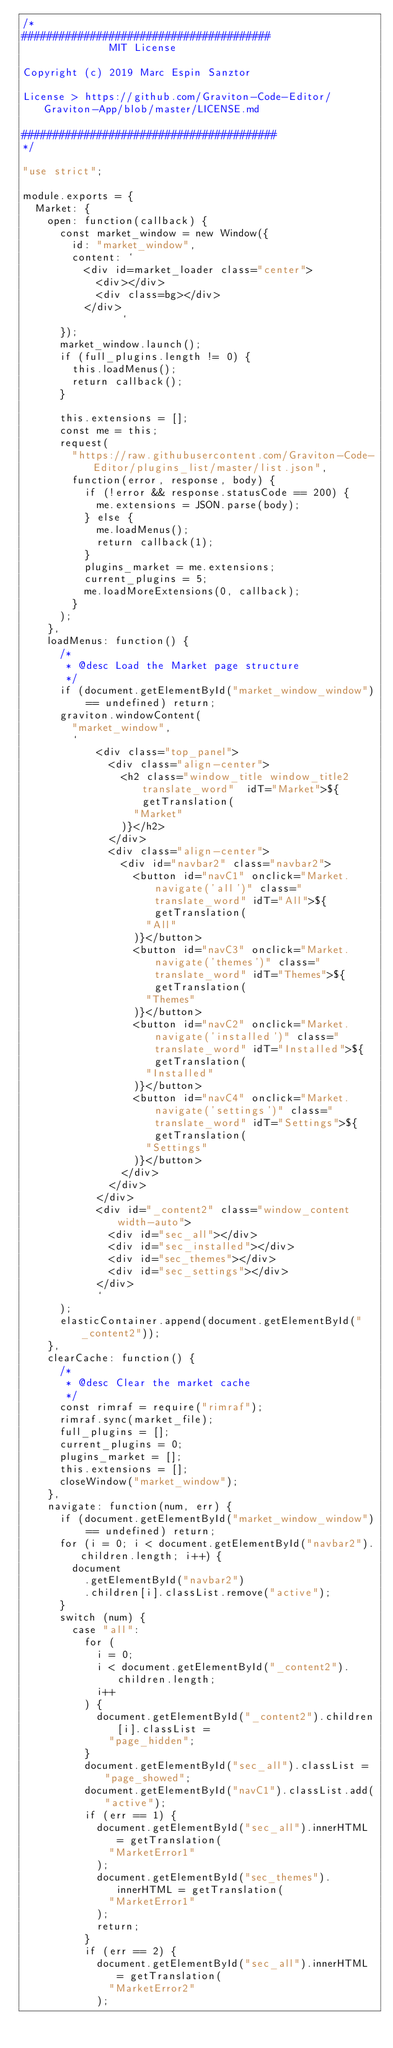<code> <loc_0><loc_0><loc_500><loc_500><_JavaScript_>/*
########################################
              MIT License

Copyright (c) 2019 Marc Espin Sanztor

License > https://github.com/Graviton-Code-Editor/Graviton-App/blob/master/LICENSE.md

#########################################
*/

"use strict";

module.exports = {
  Market: {
    open: function(callback) {
      const market_window = new Window({
        id: "market_window",
        content: `
          <div id=market_loader class="center">
            <div></div>
            <div class=bg></div>
          </div>
                `
      });
      market_window.launch();
      if (full_plugins.length != 0) {
        this.loadMenus();
        return callback();
      }
      
      this.extensions = [];
      const me = this;
      request(
        "https://raw.githubusercontent.com/Graviton-Code-Editor/plugins_list/master/list.json",
        function(error, response, body) {
          if (!error && response.statusCode == 200) {
            me.extensions = JSON.parse(body);
          } else {
            me.loadMenus();
            return callback(1);
          }
          plugins_market = me.extensions;
          current_plugins = 5;
          me.loadMoreExtensions(0, callback);
        }
      );
    },
    loadMenus: function() {
      /*
       * @desc Load the Market page structure
       */
      if (document.getElementById("market_window_window") == undefined) return;
      graviton.windowContent(
        "market_window",
        `
            <div class="top_panel">
              <div class="align-center">
                <h2 class="window_title window_title2 translate_word"  idT="Market">${getTranslation(
                  "Market"
                )}</h2>
              </div>
              <div class="align-center">
                <div id="navbar2" class="navbar2">
                  <button id="navC1" onclick="Market.navigate('all')" class="translate_word" idT="All">${getTranslation(
                    "All"
                  )}</button>
                  <button id="navC3" onclick="Market.navigate('themes')" class="translate_word" idT="Themes">${getTranslation(
                    "Themes"
                  )}</button>
                  <button id="navC2" onclick="Market.navigate('installed')" class="translate_word" idT="Installed">${getTranslation(
                    "Installed"
                  )}</button>
                  <button id="navC4" onclick="Market.navigate('settings')" class="translate_word" idT="Settings">${getTranslation(
                    "Settings"
                  )}</button>
                </div>
              </div>
            </div>
            <div id="_content2" class="window_content width-auto">
              <div id="sec_all"></div>
              <div id="sec_installed"></div>
              <div id="sec_themes"></div>
              <div id="sec_settings"></div>
            </div>  
            `
      );
      elasticContainer.append(document.getElementById("_content2"));
    },
    clearCache: function() {
      /*
       * @desc Clear the market cache
       */
      const rimraf = require("rimraf");
      rimraf.sync(market_file);
      full_plugins = [];
      current_plugins = 0;
      plugins_market = [];
      this.extensions = [];
      closeWindow("market_window");
    },
    navigate: function(num, err) {
      if (document.getElementById("market_window_window") == undefined) return;
      for (i = 0; i < document.getElementById("navbar2").children.length; i++) {
        document
          .getElementById("navbar2")
          .children[i].classList.remove("active");
      }
      switch (num) {
        case "all":
          for (
            i = 0;
            i < document.getElementById("_content2").children.length;
            i++
          ) {
            document.getElementById("_content2").children[i].classList =
              "page_hidden";
          }
          document.getElementById("sec_all").classList = "page_showed";
          document.getElementById("navC1").classList.add("active");
          if (err == 1) {
            document.getElementById("sec_all").innerHTML = getTranslation(
              "MarketError1"
            );
            document.getElementById("sec_themes").innerHTML = getTranslation(
              "MarketError1"
            );
            return;
          }
          if (err == 2) {
            document.getElementById("sec_all").innerHTML = getTranslation(
              "MarketError2"
            );</code> 